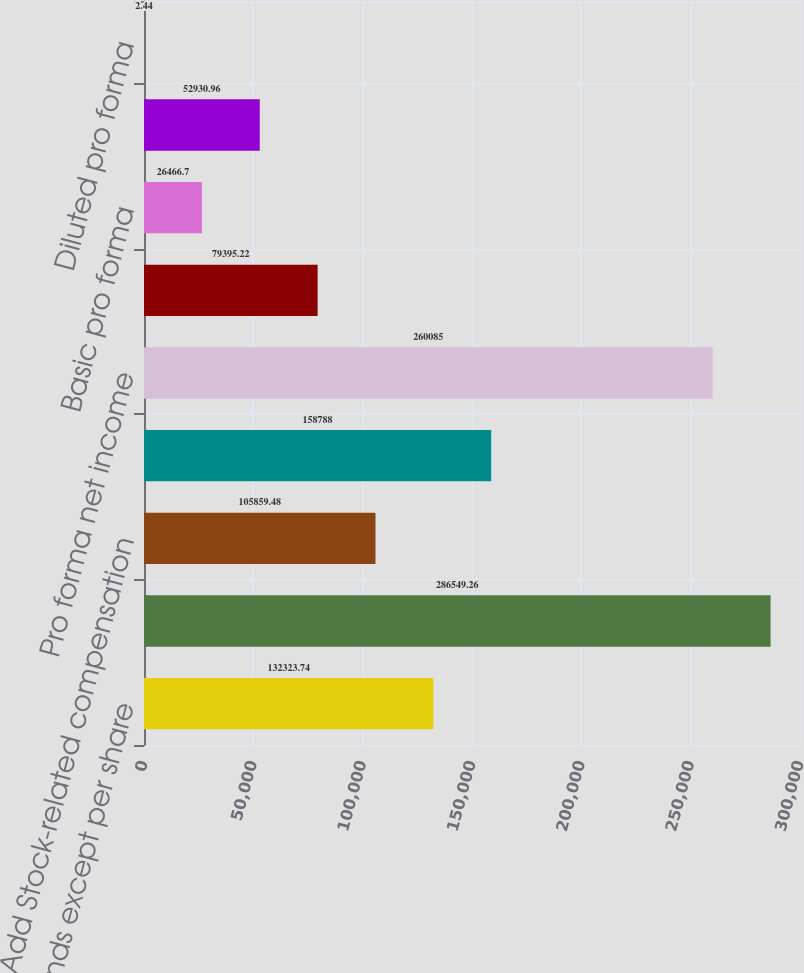Convert chart to OTSL. <chart><loc_0><loc_0><loc_500><loc_500><bar_chart><fcel>(in thousands except per share<fcel>Net income as reported<fcel>Add Stock-related compensation<fcel>Deduct Stock-related<fcel>Pro forma net income<fcel>Basic as reported<fcel>Basic pro forma<fcel>Diluted as reported<fcel>Diluted pro forma<nl><fcel>132324<fcel>286549<fcel>105859<fcel>158788<fcel>260085<fcel>79395.2<fcel>26466.7<fcel>52931<fcel>2.44<nl></chart> 